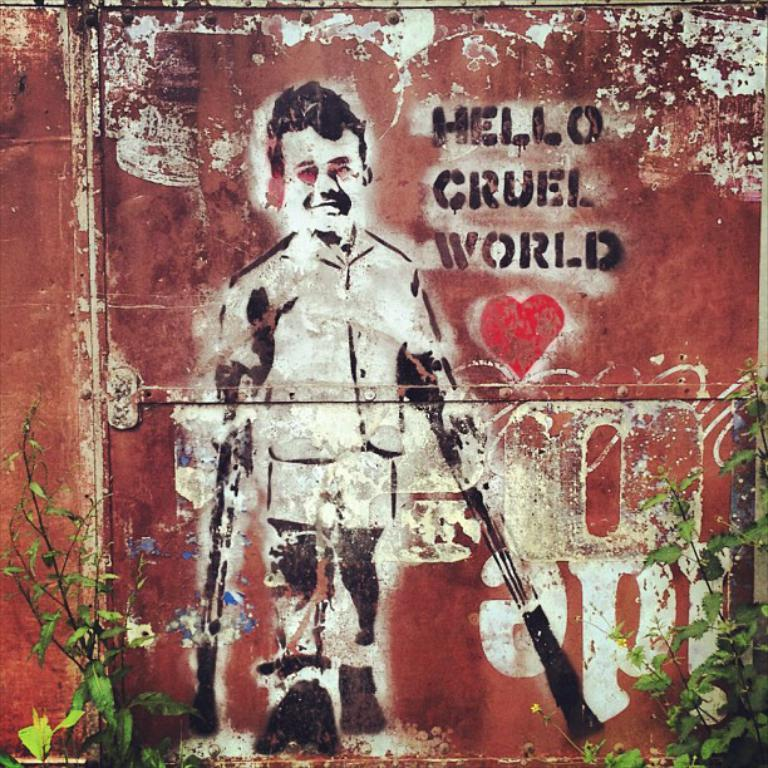What is on the wall in the image? There is Graffiti on the wall. What else can be seen in front of the wall? There are plants in front of the wall. What else is written on the wall besides the Graffiti? There is some text written on the wall. How many hours does the neck beam sleep in the image? There is no neck beam or sleeping figure present in the image. 